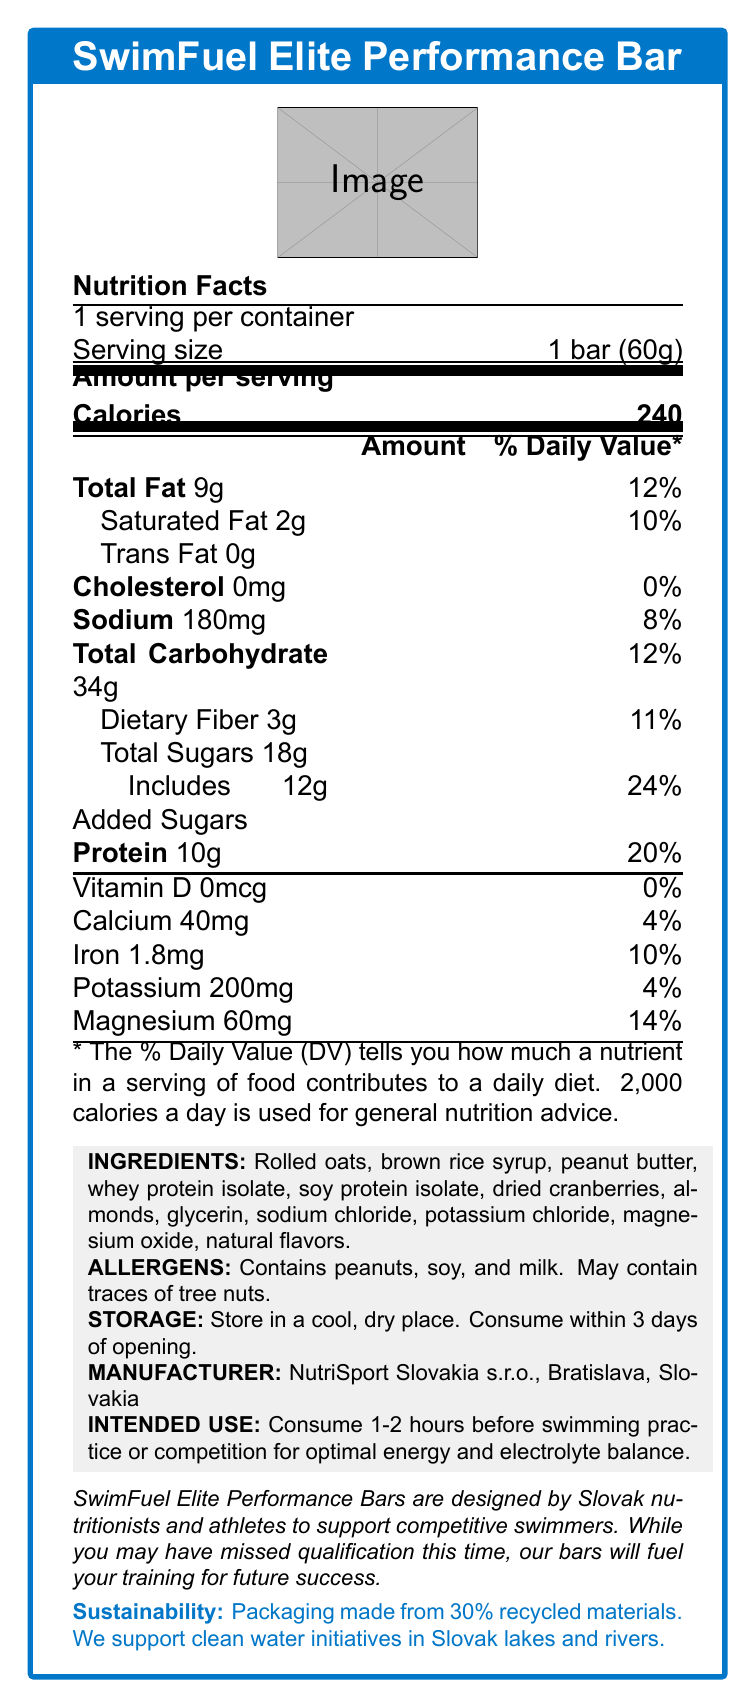what is the serving size for the SwimFuel Elite Performance Bar? The serving size is explicitly stated as "1 bar (60g)" in the nutrition facts section.
Answer: 1 bar (60g) how many calories are in one serving of the SwimFuel Elite Performance Bar? The label indicates that there are 240 calories per serving.
Answer: 240 calories how much protein does the SwimFuel Elite Performance Bar contain per serving? The document lists the protein content per serving as 10g.
Answer: 10g what percentage of the daily value for sodium does the bar provide? The bar provides 180mg of sodium, which is 8% of the daily value.
Answer: 8% what allergens are present in the SwimFuel Elite Performance Bar? The allergens listed are peanuts, soy, milk, and the bar may contain traces of tree nuts.
Answer: Peanuts, soy, milk, and may contain traces of tree nuts. which of the following minerals is not listed on the nutrition label of the SwimFuel Elite Performance Bar? A. Iron B. Zinc C. Calcium D. Magnesium Zinc is not mentioned in the list of minerals provided on the nutrition label.
Answer: B. Zinc how many grams of total fat are in the bar, and what is the percentage of daily value it provides? The label states that one bar contains 9g of total fat, contributing to 12% of the daily value.
Answer: 9g, 12% what is the recommended time frame for consuming the bar for optimal performance in swimming practice or competition? A. 15 minutes before B. 1-2 hours before C. After the practice D. Only on competition days The intended use section advises consuming the bar 1-2 hours before swimming practice or competition.
Answer: B. 1-2 hours before the bar contains added sugars. what is the amount and percentage of the daily value provided by these added sugars? The label indicates 12g of added sugars, which constitute 24% of the daily value.
Answer: 12g, 24% is the packaging of the SwimFuel Elite Performance Bar environmentally sustainable? Yes/No The sustainability section mentions that the packaging is made from 30% recycled materials.
Answer: Yes summarize the main features and purpose of the SwimFuel Elite Performance Bar. The document highlights the nutritional composition of the bar, its intended use, allergen information, sustainability efforts, and its design for competitive swimmers.
Answer: The SwimFuel Elite Performance Bar is a high-energy bar designed specifically for competitive swimmers. Each serving (1 bar) provides 240 calories, 10g of protein, and essential minerals such as magnesium and potassium. It contains allergens like peanuts, soy, and milk, and should be consumed 1-2 hours before swimming practice or competition for optimal energy and electrolyte balance. The packaging is environmentally friendly, made from 30% recycled materials, and the company supports clean water initiatives in Slovak lakes and rivers. who manufactures the SwimFuel Elite Performance Bar? The manufacturer information section indicates that NutriSport Slovakia s.r.o., located in Bratislava, Slovakia, produces the bar.
Answer: NutriSport Slovakia s.r.o., Bratislava, Slovakia what is the total carbohydrate content and its daily value percentage? The nutrition label shows that the bar contains 34g of total carbohydrates, contributing 12% of the daily value.
Answer: 34g, 12% how long should the bar be consumed after opening for optimal freshness? The storage instructions specify that the bar should be consumed within 3 days of opening.
Answer: Within 3 days does the SwimFuel Elite Performance Bar contain any trans fat? The nutrition label indicates that the bar contains 0g of trans fat.
Answer: No what is the brand story behind the SwimFuel Elite Performance Bar? The brand story section provides this narrative, emphasizing the bar's development by Slovak experts and its goal to support competitive swimmers.
Answer: SwimFuel Elite Performance Bars are designed by Slovak nutritionists and athletes to support competitive swimmers. They aim to fuel your training for future success, even if you missed qualification this time. does the SwimFuel Elite Performance Bar contain vitamin D? The label shows that the bar contains 0mcg of vitamin D (0% daily value).
Answer: No what other ingredients are included in the energy bar besides the main nutrients listed? The list of ingredients includes these items, as stated in the ingredients section of the document.
Answer: Rolled oats, brown rice syrup, peanut butter, whey protein isolate, soy protein isolate, dried cranberries, almonds, glycerin, sodium chloride, potassium chloride, magnesium oxide, natural flavors. what is the magnesium content in the bar, and what percentage of daily value does it provide? The label indicates that the bar contains 60mg of magnesium, contributing 14% of the daily value.
Answer: 60mg, 14% is the SwimFuel Elite Performance Bar suitable for a competitive swimmer who has a tree nut allergy? Although it mentions the bar contains traces of tree nuts, it is not categorically stated whether it is safe for someone with a tree nut allergy.
Answer: Not enough information 